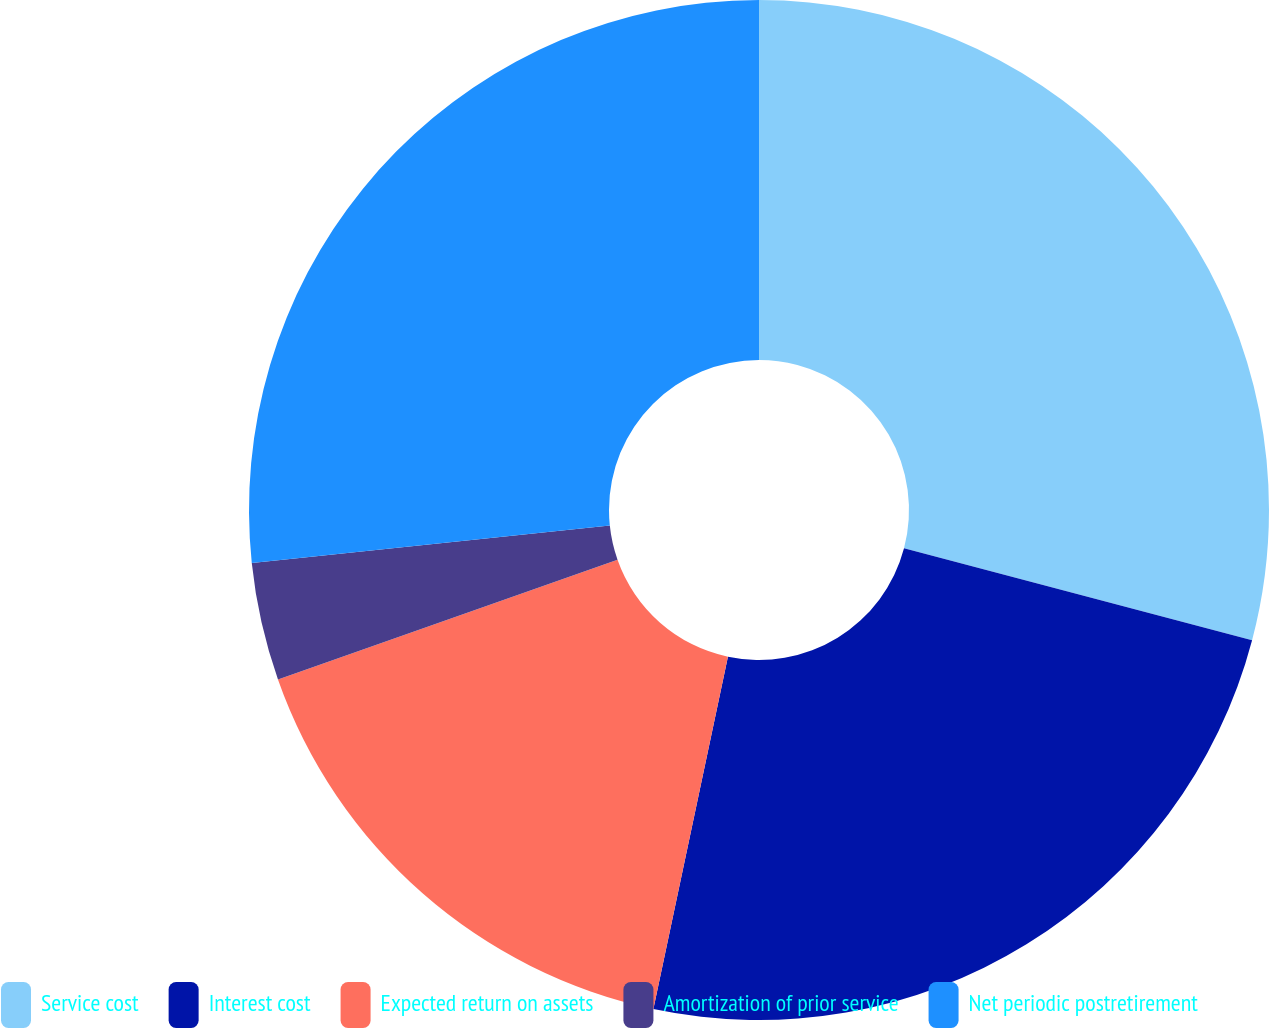Convert chart to OTSL. <chart><loc_0><loc_0><loc_500><loc_500><pie_chart><fcel>Service cost<fcel>Interest cost<fcel>Expected return on assets<fcel>Amortization of prior service<fcel>Net periodic postretirement<nl><fcel>29.11%<fcel>24.21%<fcel>16.29%<fcel>3.73%<fcel>26.66%<nl></chart> 